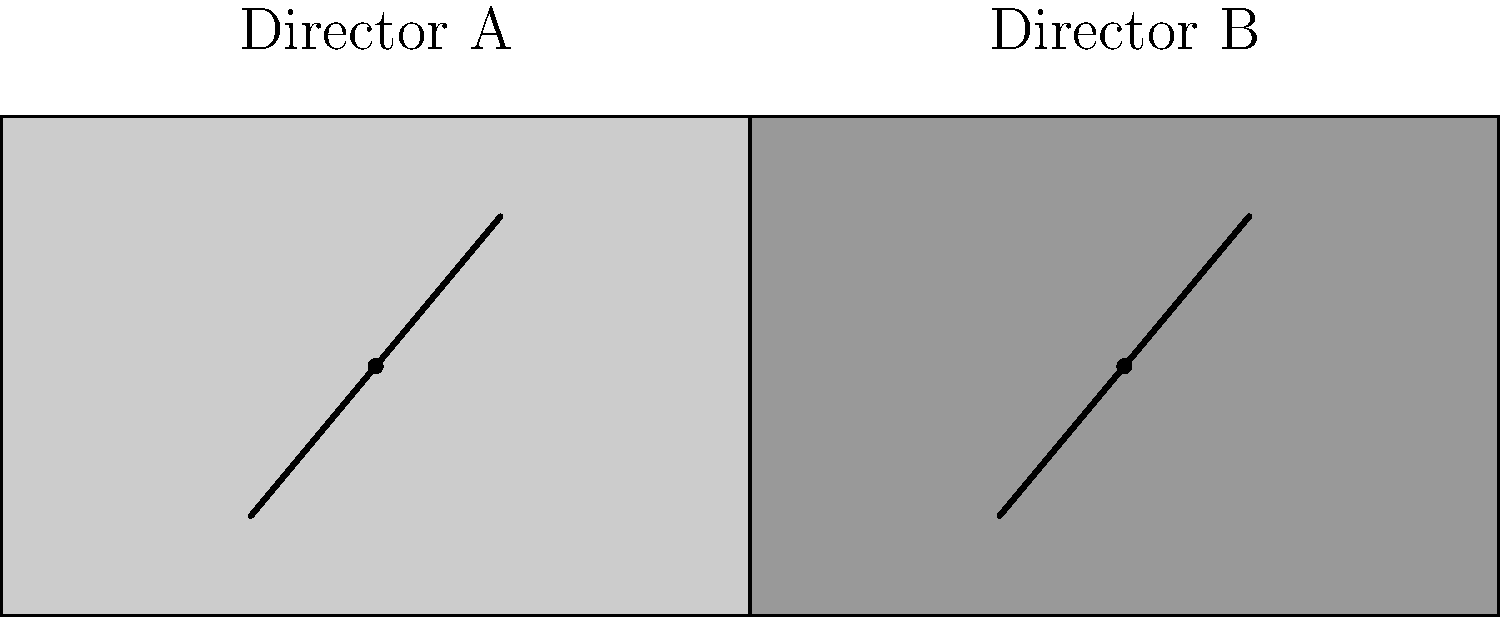Based on the simplified visual representation above, which Golden Age director is more likely to use dramatic lighting techniques and strong contrasts in their film compositions? To answer this question, we need to analyze the visual styles represented in the diagram:

1. The diagram shows two simplified film stills, one for Director A and one for Director B.

2. Director A's frame (left side):
   - Uses a lighter shade of gray
   - Has a diagonal line from bottom-left to top-right
   - Contains a central focal point (dot)

3. Director B's frame (right side):
   - Uses a darker shade of gray
   - Has a diagonal line from bottom-left to top-right
   - Contains a central focal point (dot)

4. The key difference is the overall shading:
   - Director B's frame is noticeably darker

5. In the context of Golden Age cinema:
   - Darker tones and higher contrast are often associated with dramatic lighting techniques
   - These techniques were prominently used in film noir and by directors known for their visual style

6. Directors known for dramatic lighting and strong contrasts include:
   - Orson Welles (e.g., "Citizen Kane")
   - Alfred Hitchcock (e.g., "Psycho")
   - Billy Wilder (e.g., "Double Indemnity")

Given the darker tones in Director B's frame, this style is more consistent with dramatic lighting techniques and strong contrasts commonly associated with certain Golden Age directors.
Answer: Director B 